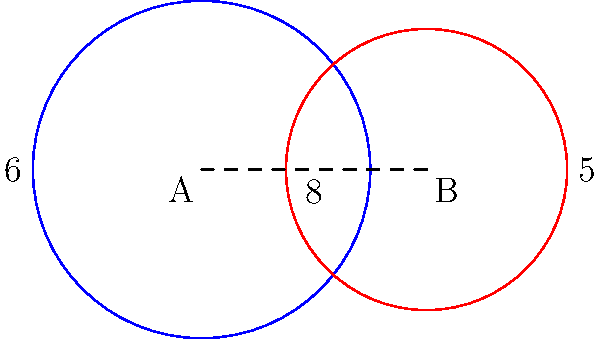At the Kenan Stadium practice field, Coach Mack Brown sets up two circular training zones for the Tar Heels football team. Zone A has a radius of 6 yards, and Zone B has a radius of 5 yards. The centers of these zones are 8 yards apart. Calculate the area of the overlapping region between these two zones, rounded to the nearest square yard. Let's approach this step-by-step:

1) First, we need to find the distance from the center of each circle to the line of intersection. Let's call this distance $x$ for circle A and $y$ for circle B.

2) Using the Pythagorean theorem:
   $x^2 + y^2 = 8^2 = 64$
   $6^2 = x^2 + (8-x)^2$
   $36 = x^2 + 64 - 16x + x^2$
   $36 = 2x^2 - 16x + 64$
   $2x^2 - 16x + 28 = 0$
   $x^2 - 8x + 14 = 0$

3) Solving this quadratic equation:
   $x = \frac{8 \pm \sqrt{64 - 56}}{2} = \frac{8 \pm \sqrt{8}}{2} = 4 \pm \sqrt{2}$

4) We take the smaller value: $x = 4 - \sqrt{2}$

5) Now we can find $y$: $y = 8 - x = 4 + \sqrt{2}$

6) The area of the overlapping region is given by:
   $A = r_1^2 \arccos(\frac{x}{r_1}) + r_2^2 \arccos(\frac{y}{r_2}) - xy$

7) Substituting the values:
   $A = 36 \arccos(\frac{4-\sqrt{2}}{6}) + 25 \arccos(\frac{4+\sqrt{2}}{5}) - (4-\sqrt{2})(4+\sqrt{2})$

8) Calculating this:
   $A \approx 36 * 0.9203 + 25 * 0.6435 - 14$
   $A \approx 33.13 + 16.09 - 14$
   $A \approx 35.22$

9) Rounding to the nearest square yard:
   $A \approx 35$ square yards
Answer: 35 square yards 